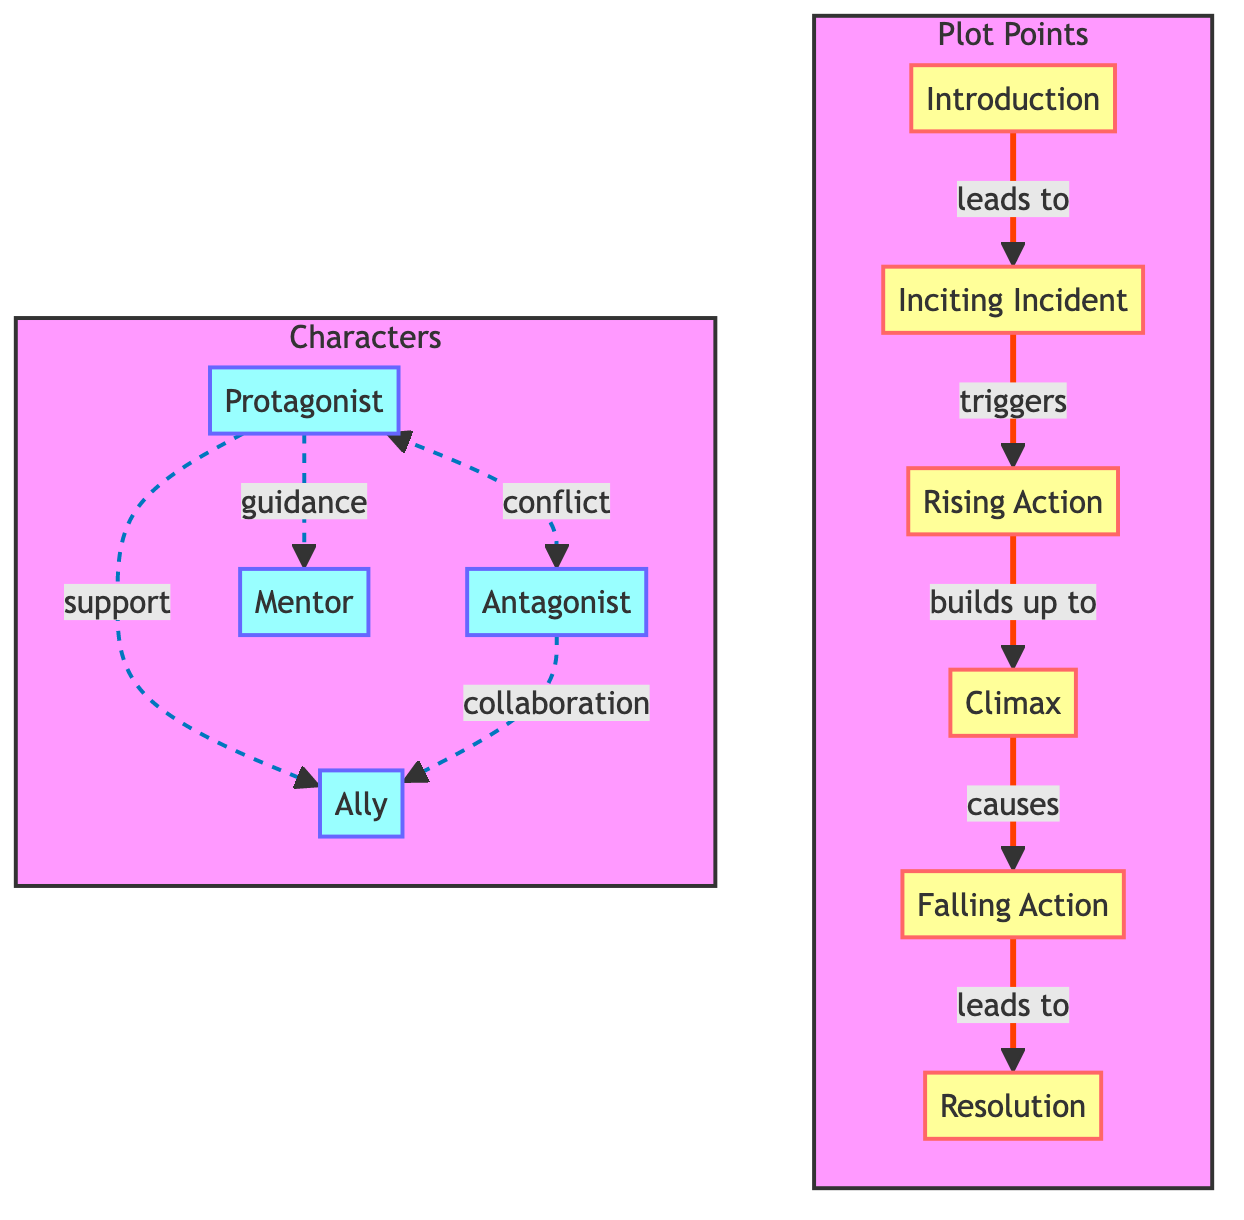What is the starting point of the plot? The starting point is indicated by the first node in the diagram, which is labeled "Introduction."
Answer: Introduction How many plot points are there in the diagram? The diagram lists six distinct plot points as nodes, from "Introduction" to "Resolution."
Answer: 6 What event does the "Inciting Incident" lead to? The arrow from "Inciting Incident" points to "Rising Action," indicating that it triggers this subsequent plot point.
Answer: Rising Action Which character interacts with the Protagonist? The diagram shows that the Protagonist interacts with multiple characters, specifically the Antagonist, Mentor, and Ally.
Answer: Antagonist, Mentor, Ally What type of interaction occurs between the Protagonist and Antagonist? The diagram clearly states the type of interaction is "conflict," occurring at the "Inciting Incident" and "Climax."
Answer: conflict What is the connection between Falling Action and Resolution? The diagram shows an arrow leading from "Falling Action" to "Resolution," indicating that Falling Action leads to the outcome of the story's conclusion.
Answer: leads to During which phases does the Protagonist receive guidance from the Mentor? The interactions between the Protagonist and the Mentor are identified in the "Rising Action" and "Falling Action" stages.
Answer: Rising Action, Falling Action Which plot point follows the Climax? After "Climax," the next plot point indicated by the arrow in the diagram is "Falling Action."
Answer: Falling Action What role do Allies play during the Rising Action? The Allies are shown to play a supportive role during the "Rising Action," in conjunction with the Protagonist's challenges.
Answer: support 